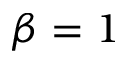<formula> <loc_0><loc_0><loc_500><loc_500>\beta = 1</formula> 